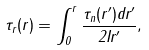Convert formula to latex. <formula><loc_0><loc_0><loc_500><loc_500>\tau _ { r } ( r ) = \int _ { 0 } ^ { r } \frac { \tau _ { n } ( r ^ { \prime } ) d r ^ { \prime } } { 2 I r ^ { \prime } } ,</formula> 